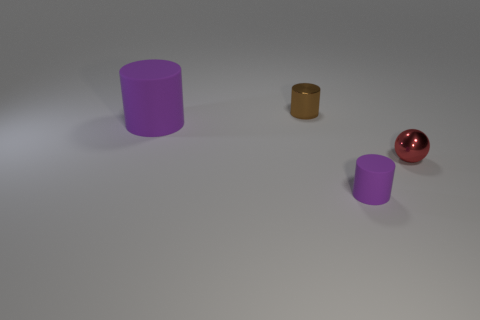Subtract all blue blocks. How many purple cylinders are left? 2 Subtract all tiny brown metal cylinders. How many cylinders are left? 2 Add 3 big brown spheres. How many objects exist? 7 Subtract all green cylinders. Subtract all red blocks. How many cylinders are left? 3 Subtract all cylinders. How many objects are left? 1 Add 2 tiny gray matte blocks. How many tiny gray matte blocks exist? 2 Subtract 2 purple cylinders. How many objects are left? 2 Subtract all purple matte cylinders. Subtract all tiny metallic spheres. How many objects are left? 1 Add 1 red metallic things. How many red metallic things are left? 2 